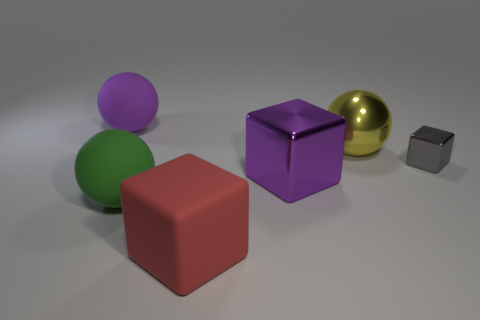Is there anything else that has the same size as the gray metal cube?
Offer a very short reply. No. The gray metal thing that is the same shape as the large red matte thing is what size?
Your response must be concise. Small. What number of other matte cubes are the same color as the matte block?
Offer a very short reply. 0. What color is the other sphere that is the same material as the large green sphere?
Your response must be concise. Purple. Are there any yellow balls that have the same size as the purple ball?
Give a very brief answer. Yes. Is the number of purple shiny objects that are behind the large red rubber object greater than the number of small gray metallic blocks left of the large purple matte object?
Provide a succinct answer. Yes. Does the purple object left of the large shiny block have the same material as the ball in front of the metallic ball?
Offer a very short reply. Yes. The shiny thing that is the same size as the metallic sphere is what shape?
Your answer should be compact. Cube. Are there any purple rubber things of the same shape as the yellow metal object?
Make the answer very short. Yes. Is the color of the block that is behind the big purple metal object the same as the large matte ball that is right of the large purple sphere?
Make the answer very short. No. 